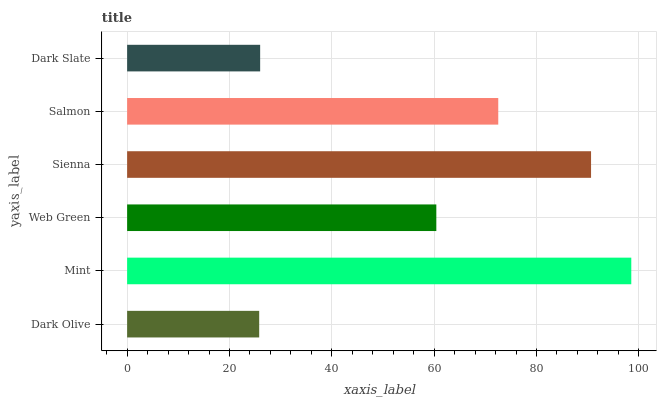Is Dark Olive the minimum?
Answer yes or no. Yes. Is Mint the maximum?
Answer yes or no. Yes. Is Web Green the minimum?
Answer yes or no. No. Is Web Green the maximum?
Answer yes or no. No. Is Mint greater than Web Green?
Answer yes or no. Yes. Is Web Green less than Mint?
Answer yes or no. Yes. Is Web Green greater than Mint?
Answer yes or no. No. Is Mint less than Web Green?
Answer yes or no. No. Is Salmon the high median?
Answer yes or no. Yes. Is Web Green the low median?
Answer yes or no. Yes. Is Dark Slate the high median?
Answer yes or no. No. Is Salmon the low median?
Answer yes or no. No. 